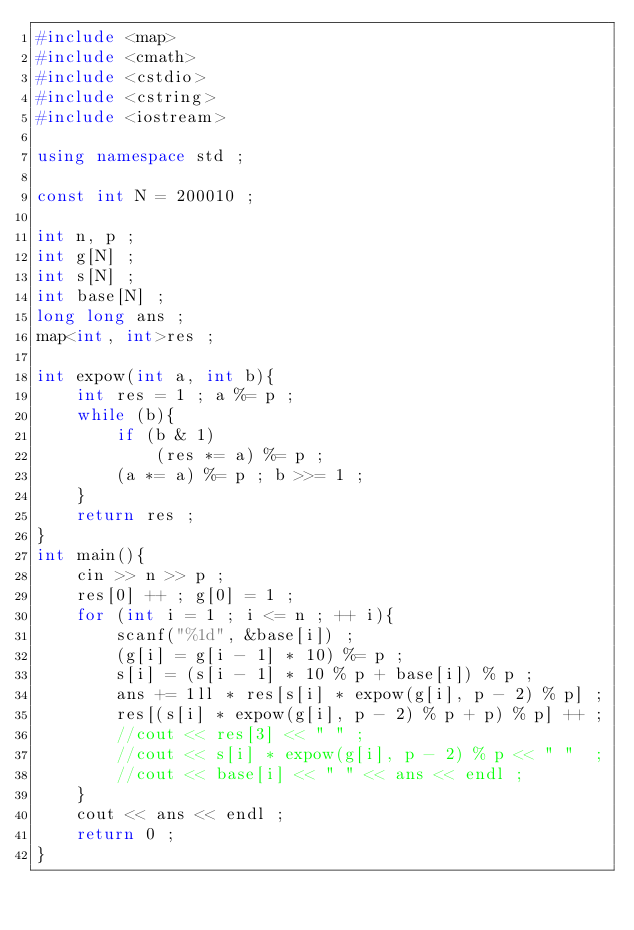<code> <loc_0><loc_0><loc_500><loc_500><_C++_>#include <map>
#include <cmath>
#include <cstdio>
#include <cstring>
#include <iostream>

using namespace std ;

const int N = 200010 ; 

int n, p ;
int g[N] ; 
int s[N] ; 
int base[N] ; 
long long ans ;
map<int, int>res ;

int expow(int a, int b){
	int res = 1 ; a %= p ; 
	while (b){
		if (b & 1)
			(res *= a) %= p ;
		(a *= a) %= p ; b >>= 1 ;
	}
	return res ;
}
int main(){
	cin >> n >> p ;	
	res[0] ++ ; g[0] = 1 ; 
	for (int i = 1 ; i <= n ; ++ i){
		scanf("%1d", &base[i]) ;
		(g[i] = g[i - 1] * 10) %= p ;
		s[i] = (s[i - 1] * 10 % p + base[i]) % p ;
		ans += 1ll * res[s[i] * expow(g[i], p - 2) % p] ;
		res[(s[i] * expow(g[i], p - 2) % p + p) % p] ++ ;
		//cout << res[3] << " " ;
		//cout << s[i] * expow(g[i], p - 2) % p << " "  ;
		//cout << base[i] << " " << ans << endl ;
	}	
	cout << ans << endl ;
	return 0 ; 
}</code> 